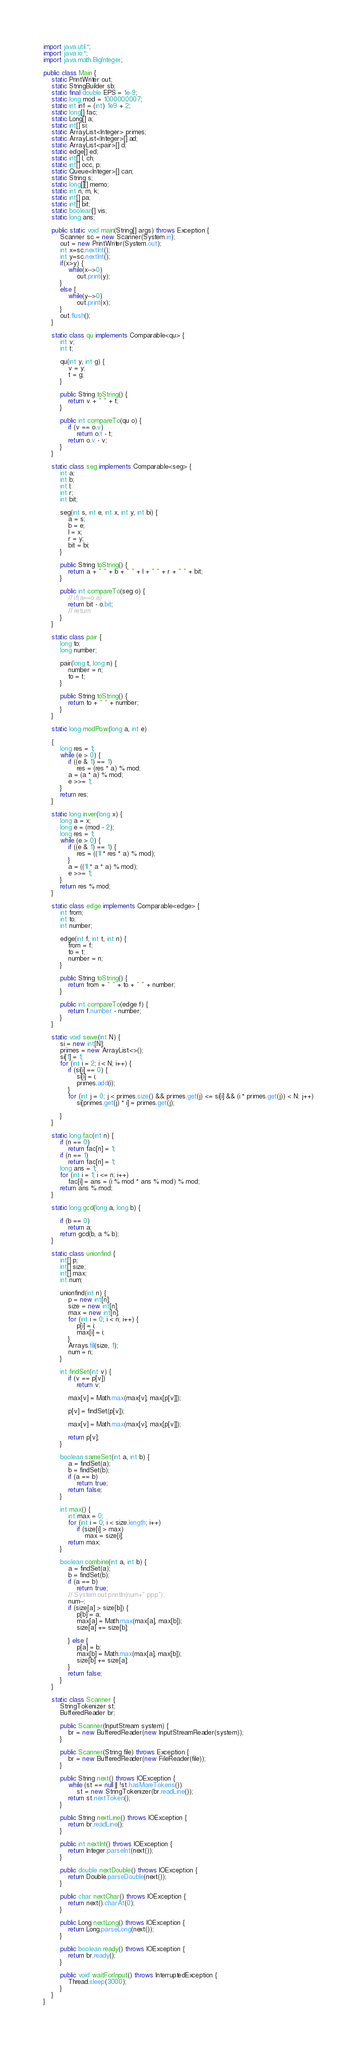<code> <loc_0><loc_0><loc_500><loc_500><_Java_>import java.util.*;
import java.io.*;
import java.math.BigInteger;

public class Main {
	static PrintWriter out;
	static StringBuilder sb;
	static final double EPS = 1e-9;
	static long mod = 1000000007;
	static int inf = (int) 1e9 + 2;
	static long[] fac;
	static Long[] a;
	static int[] si;
	static ArrayList<Integer> primes;
	static ArrayList<Integer>[] ad;
	static ArrayList<pair>[] d;
	static edge[] ed;
	static int[] l, ch;
	static int[] occ, p;
	static Queue<Integer>[] can;
	static String s;
	static long[][] memo;
	static int n, m, k;
	static int[] pa;
	static int[] bit;
	static boolean[] vis;
	static long ans;

	public static void main(String[] args) throws Exception {
		Scanner sc = new Scanner(System.in);
		out = new PrintWriter(System.out);
		int x=sc.nextInt();
		int y=sc.nextInt();
		if(x>y) {
			while(x-->0)
				out.print(y);
		}
		else {
			while(y-->0)
				out.print(x);
		}
		out.flush();
	}

	static class qu implements Comparable<qu> {
		int v;
		int t;

		qu(int y, int g) {
			v = y;
			t = g;
		}

		public String toString() {
			return v + " " + t;
		}

		public int compareTo(qu o) {
			if (v == o.v)
				return o.t - t;
			return o.v - v;
		}
	}

	static class seg implements Comparable<seg> {
		int a;
		int b;
		int l;
		int r;
		int bit;

		seg(int s, int e, int x, int y, int bi) {
			a = s;
			b = e;
			l = x;
			r = y;
			bit = bi;
		}

		public String toString() {
			return a + " " + b + " " + l + " " + r + " " + bit;
		}

		public int compareTo(seg o) {
			// if(a==o.a)
			return bit - o.bit;
			// return
		}
	}

	static class pair {
		long to;
		long number;

		pair(long t, long n) {
			number = n;
			to = t;
		}

		public String toString() {
			return to + " " + number;
		}
	}

	static long modPow(long a, int e)

	{
		long res = 1;
		while (e > 0) {
			if ((e & 1) == 1)
				res = (res * a) % mod;
			a = (a * a) % mod;
			e >>= 1;
		}
		return res;
	}

	static long inver(long x) {
		long a = x;
		long e = (mod - 2);
		long res = 1;
		while (e > 0) {
			if ((e & 1) == 1) {
				res = ((1l * res * a) % mod);
			}
			a = ((1l * a * a) % mod);
			e >>= 1;
		}
		return res % mod;
	}

	static class edge implements Comparable<edge> {
		int from;
		int to;
		int number;

		edge(int f, int t, int n) {
			from = f;
			to = t;
			number = n;
		}

		public String toString() {
			return from + " " + to + " " + number;
		}

		public int compareTo(edge f) {
			return f.number - number;
		}
	}

	static void seive(int N) {
		si = new int[N];
		primes = new ArrayList<>();
		si[1] = 1;
		for (int i = 2; i < N; i++) {
			if (si[i] == 0) {
				si[i] = i;
				primes.add(i);
			}
			for (int j = 0; j < primes.size() && primes.get(j) <= si[i] && (i * primes.get(j)) < N; j++)
				si[primes.get(j) * i] = primes.get(j);

		}
	}

	static long fac(int n) {
		if (n == 0)
			return fac[n] = 1;
		if (n == 1)
			return fac[n] = 1;
		long ans = 1;
		for (int i = 1; i <= n; i++)
			fac[i] = ans = (i % mod * ans % mod) % mod;
		return ans % mod;
	}

	static long gcd(long a, long b) {

		if (b == 0)
			return a;
		return gcd(b, a % b);
	}

	static class unionfind {
		int[] p;
		int[] size;
		int[] max;
		int num;

		unionfind(int n) {
			p = new int[n];
			size = new int[n];
			max = new int[n];
			for (int i = 0; i < n; i++) {
				p[i] = i;
				max[i] = i;
			}
			Arrays.fill(size, 1);
			num = n;
		}

		int findSet(int v) {
			if (v == p[v])
				return v;

			max[v] = Math.max(max[v], max[p[v]]);

			p[v] = findSet(p[v]);

			max[v] = Math.max(max[v], max[p[v]]);

			return p[v];
		}

		boolean sameSet(int a, int b) {
			a = findSet(a);
			b = findSet(b);
			if (a == b)
				return true;
			return false;
		}

		int max() {
			int max = 0;
			for (int i = 0; i < size.length; i++)
				if (size[i] > max)
					max = size[i];
			return max;
		}

		boolean combine(int a, int b) {
			a = findSet(a);
			b = findSet(b);
			if (a == b)
				return true;
			// System.out.println(num+" ppp");
			num--;
			if (size[a] > size[b]) {
				p[b] = a;
				max[a] = Math.max(max[a], max[b]);
				size[a] += size[b];

			} else {
				p[a] = b;
				max[b] = Math.max(max[a], max[b]);
				size[b] += size[a];
			}
			return false;
		}
	}

	static class Scanner {
		StringTokenizer st;
		BufferedReader br;

		public Scanner(InputStream system) {
			br = new BufferedReader(new InputStreamReader(system));
		}

		public Scanner(String file) throws Exception {
			br = new BufferedReader(new FileReader(file));
		}

		public String next() throws IOException {
			while (st == null || !st.hasMoreTokens())
				st = new StringTokenizer(br.readLine());
			return st.nextToken();
		}

		public String nextLine() throws IOException {
			return br.readLine();
		}

		public int nextInt() throws IOException {
			return Integer.parseInt(next());
		}

		public double nextDouble() throws IOException {
			return Double.parseDouble(next());
		}

		public char nextChar() throws IOException {
			return next().charAt(0);
		}

		public Long nextLong() throws IOException {
			return Long.parseLong(next());
		}

		public boolean ready() throws IOException {
			return br.ready();
		}

		public void waitForInput() throws InterruptedException {
			Thread.sleep(3000);
		}
	}
}</code> 